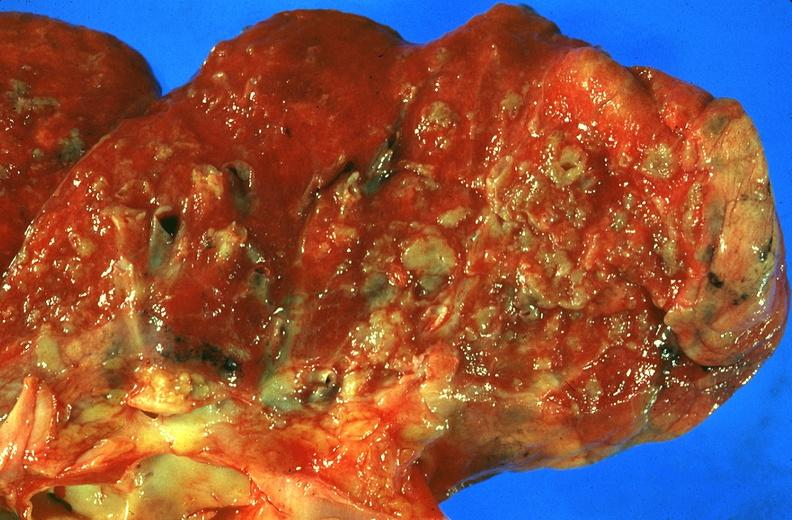s villous adenoma present?
Answer the question using a single word or phrase. No 